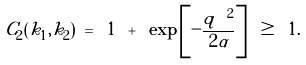Convert formula to latex. <formula><loc_0><loc_0><loc_500><loc_500>C _ { 2 } ( { k } _ { 1 } , { k } _ { 2 } ) \ = \ 1 \ + \ \exp \left [ - \frac { { q } ^ { \ 2 } } { 2 \alpha } \right ] \ \geq \ 1 .</formula> 